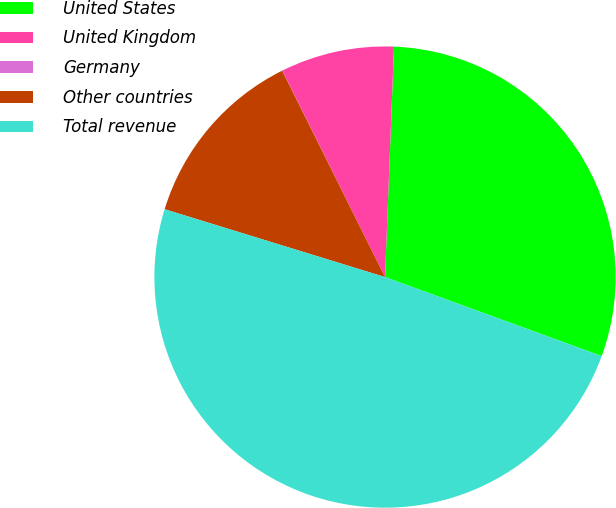Convert chart. <chart><loc_0><loc_0><loc_500><loc_500><pie_chart><fcel>United States<fcel>United Kingdom<fcel>Germany<fcel>Other countries<fcel>Total revenue<nl><fcel>29.95%<fcel>7.97%<fcel>0.01%<fcel>12.89%<fcel>49.19%<nl></chart> 